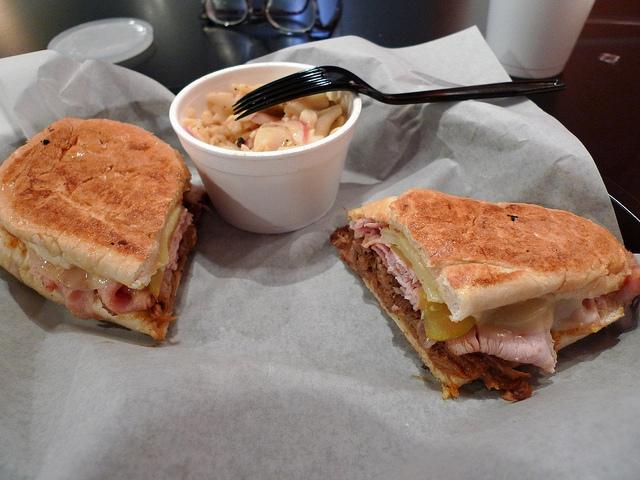Is the sandwich on a plate?
Answer briefly. No. What kind of sandwiches are on display?
Be succinct. Ham and cheese. Is there a spoon in the cup?
Short answer required. No. How many slices of meat are in the sandwiches?
Answer briefly. 2. What is in the cup?
Give a very brief answer. Salad. 